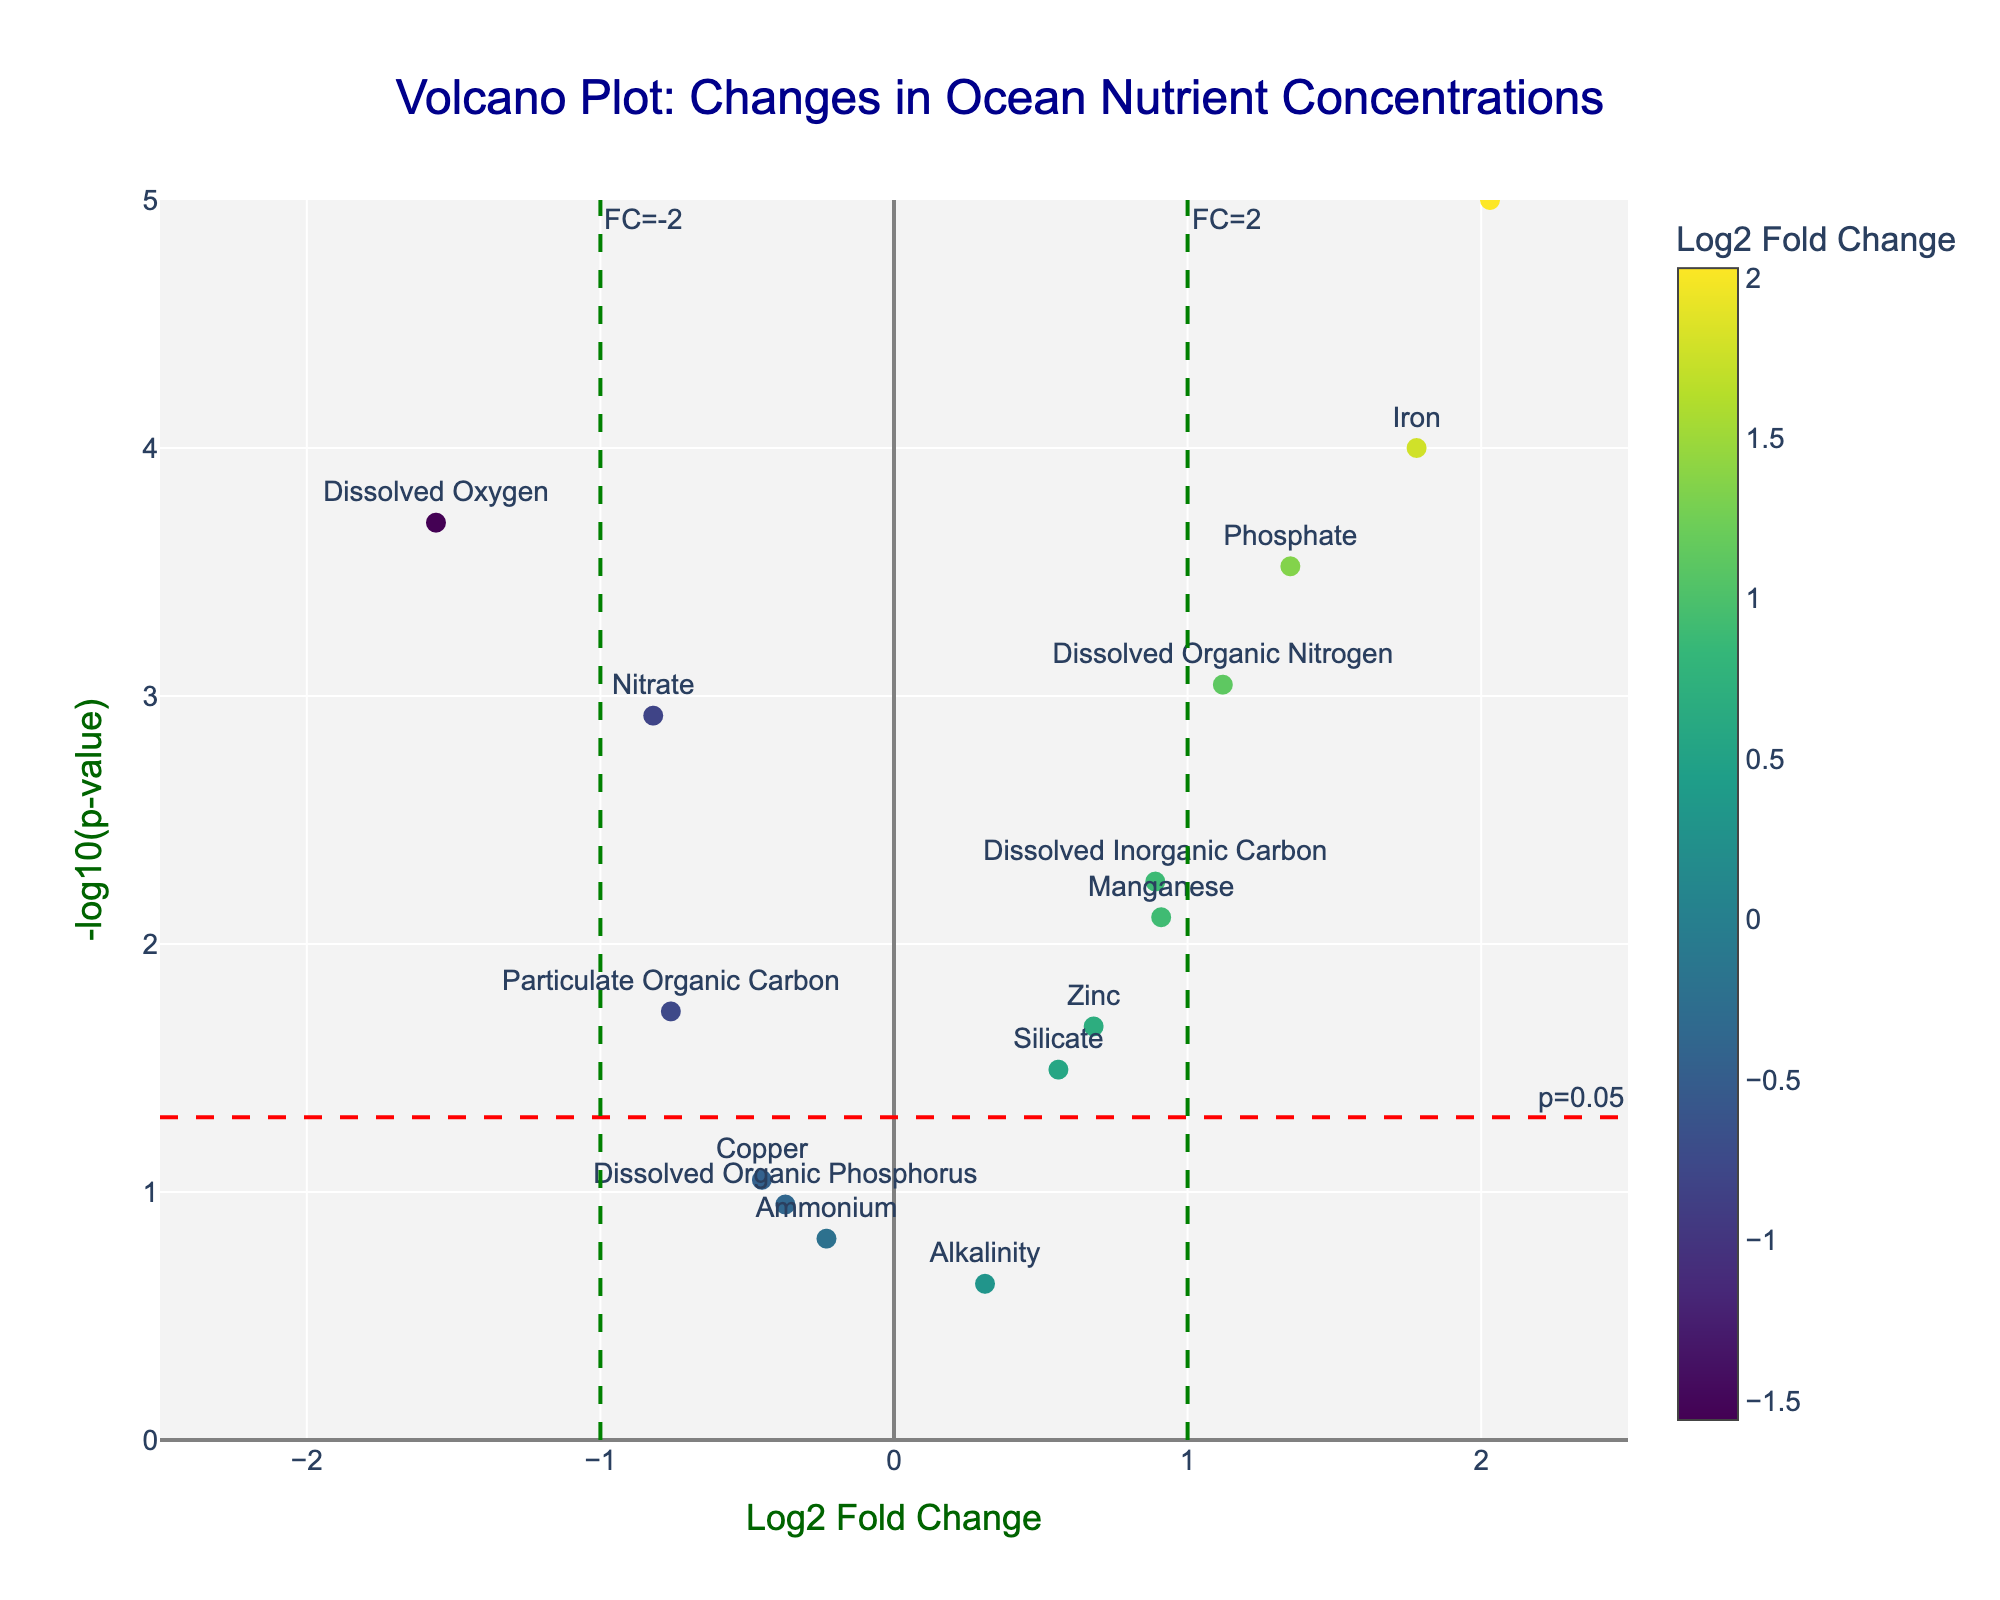How many nutrients have a statistically significant change (p < 0.05)? To determine statistical significance, we look for points above the red dashed line (y = -log10(0.05)) in the volcano plot. Count those points to find out.
Answer: 11 Which nutrient shows the highest positive Log2 Fold Change? To find the nutrient with the highest positive change, look for the point farthest to the right on the x-axis.
Answer: Chlorophyll-a Which nutrients have Log2 Fold Changes greater than 1.0? Identify points to the right of the green dashed line at x=1.0.
Answer: Phosphate, Iron, Dissolved Organic Nitrogen, Chlorophyll-a What is the Log2 Fold Change of Nitrate? Locate Nitrate on the plot and read its x-axis value (Log2 Fold Change).
Answer: -0.82 How many nutrients have a p-value less than 0.01? Identify all points above the line corresponding to -log10(0.01) on the y-axis.
Answer: 7 Which nutrient has the most negative Log2 Fold Change? Find the nutrient farthest to the left on the x-axis.
Answer: Dissolved Oxygen What is the p-value for Ammonium? Locate Ammonium on the plot and read the corresponding y-axis value converted from -log10(p-value).
Answer: 0.1542 Which nutrients fall between Log2 Fold Change values of -1 and 1 and have statistically significant p-values (p < 0.05)? Identify points within the x-axis range of [-1, 1] that lie above the red dashed line.
Answer: Silicate, Manganese, Zinc, Dissolved Inorganic Carbon, Particulate Organic Carbon Which nutrient has a p-value closest to 0.01 and what is its Log2 Fold Change? Identify the nutrient whose point is closest to the -log10(0.01) line and note its x-axis value.
Answer: Copper, -0.45 Compare the statistical significance of Iron and Phosphate. Which one is more statistically significant? Locate the points for Iron and Phosphate; the one higher on the y-axis (-log10(p-value)) is more statistically significant.
Answer: Iron 